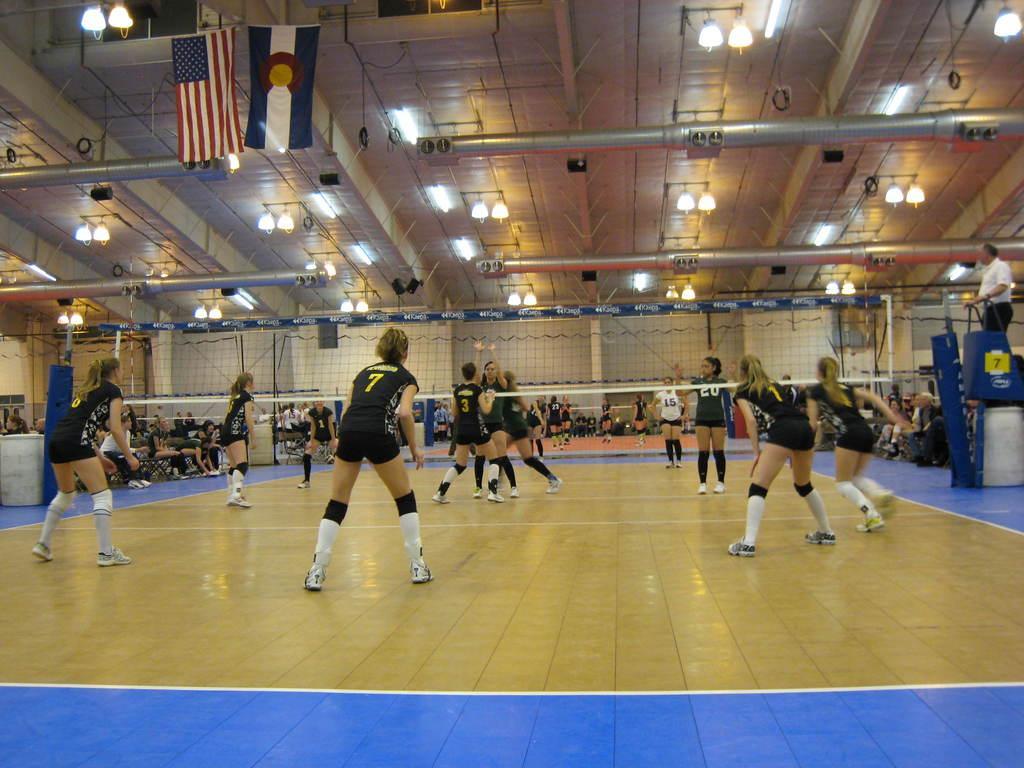Could you give a brief overview of what you see in this image? In this image in the center there are some persons standing, and they are playing something. And in the center there is net, and at the bottom there is floor. And in the background there are a group of people who are sitting and watching the game. At the top there is ceiling, poles, lights and flags. 